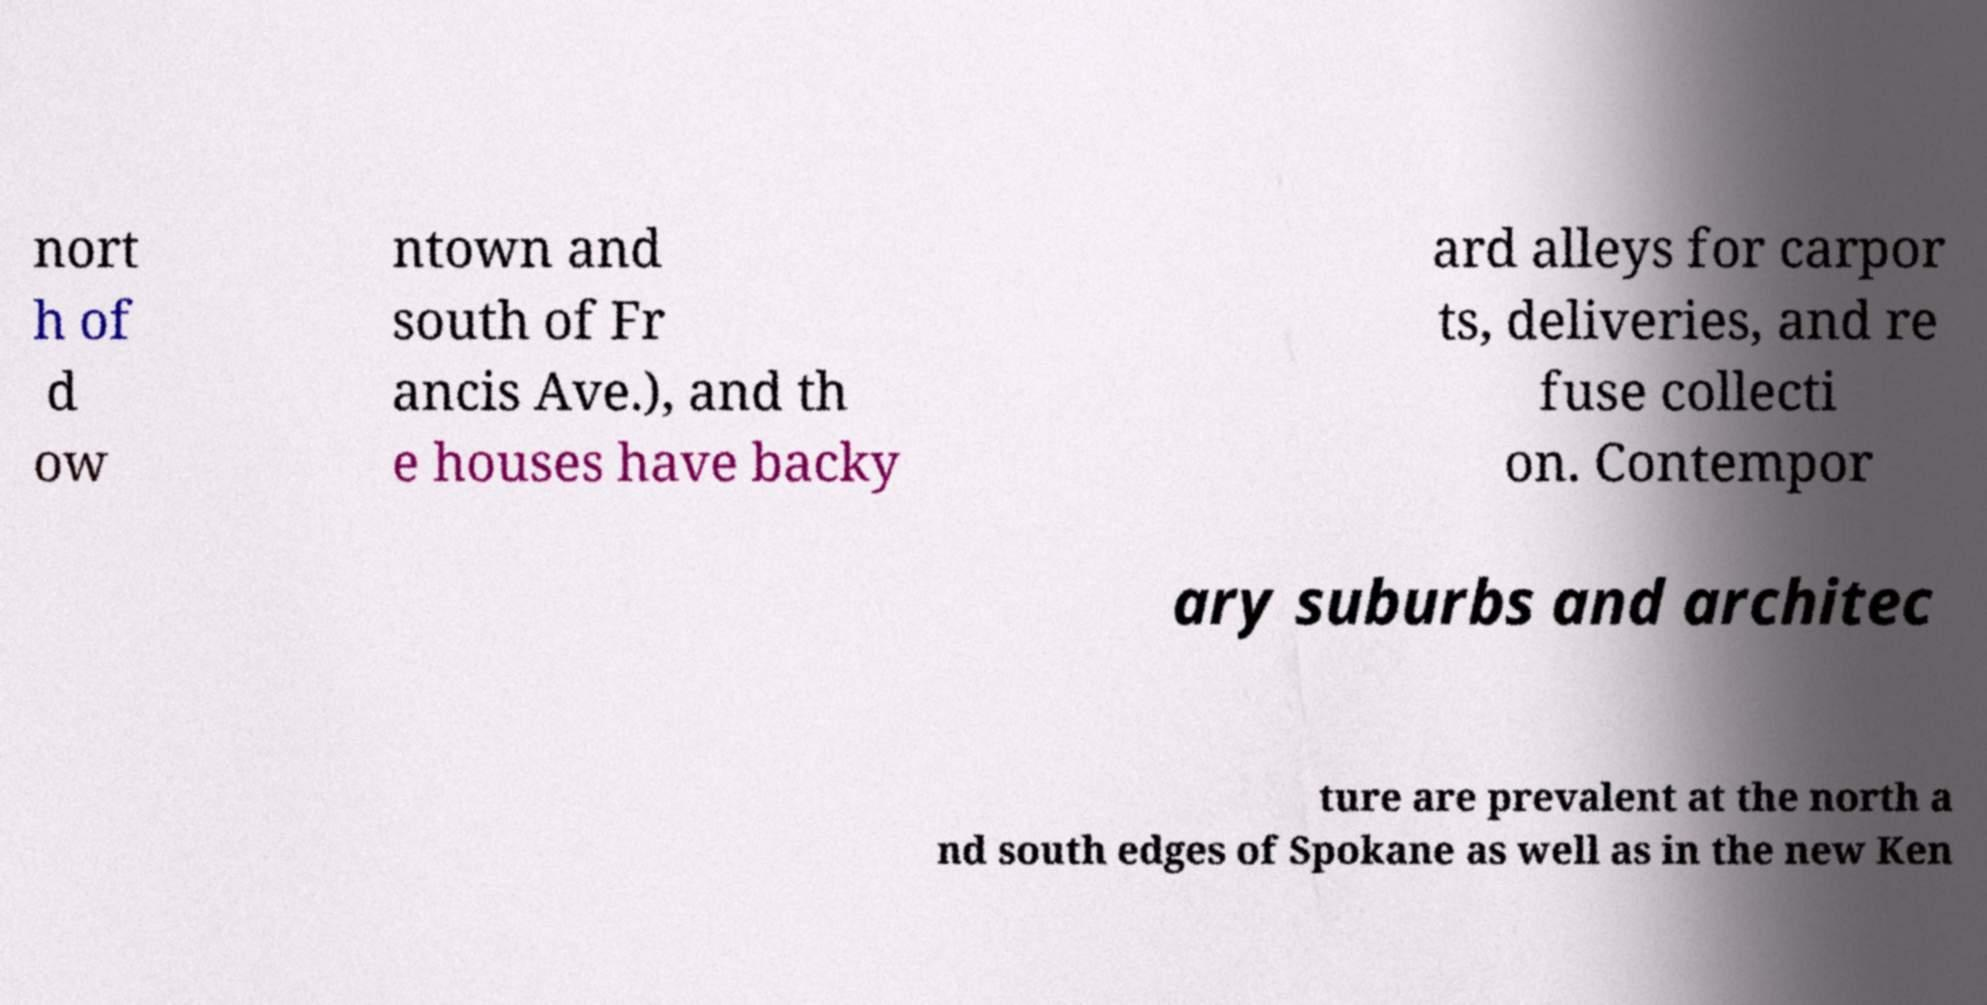Could you extract and type out the text from this image? nort h of d ow ntown and south of Fr ancis Ave.), and th e houses have backy ard alleys for carpor ts, deliveries, and re fuse collecti on. Contempor ary suburbs and architec ture are prevalent at the north a nd south edges of Spokane as well as in the new Ken 